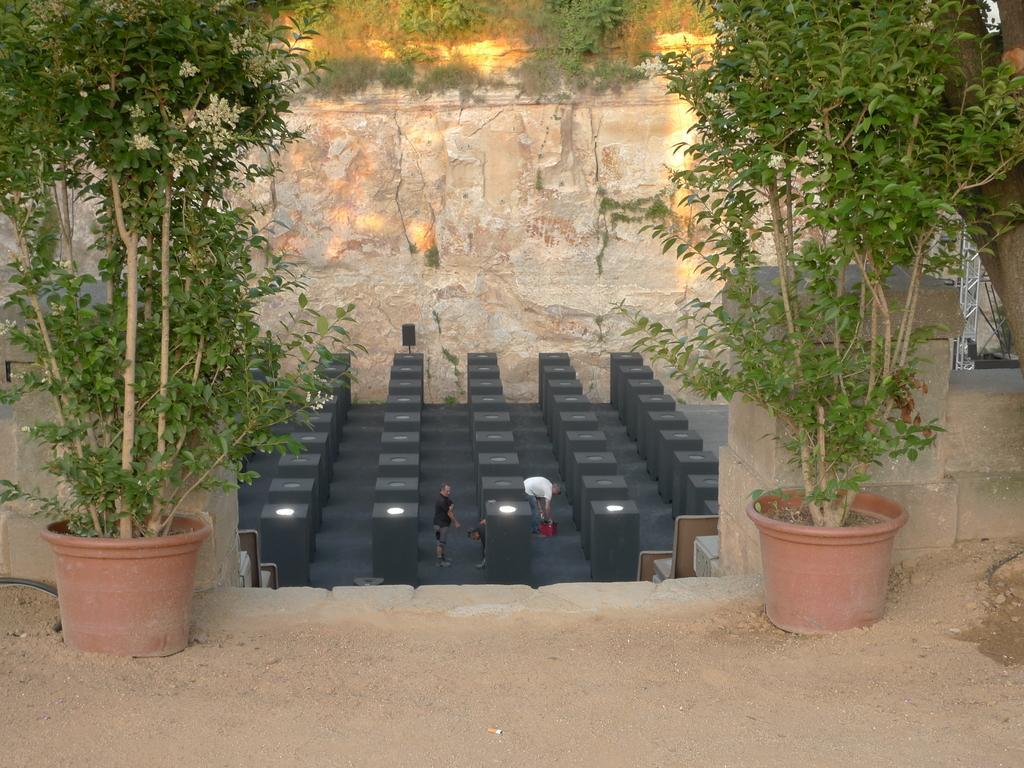Describe this image in one or two sentences. In the image we can see there are people standing on the ground and there are plants kept in the pot. 